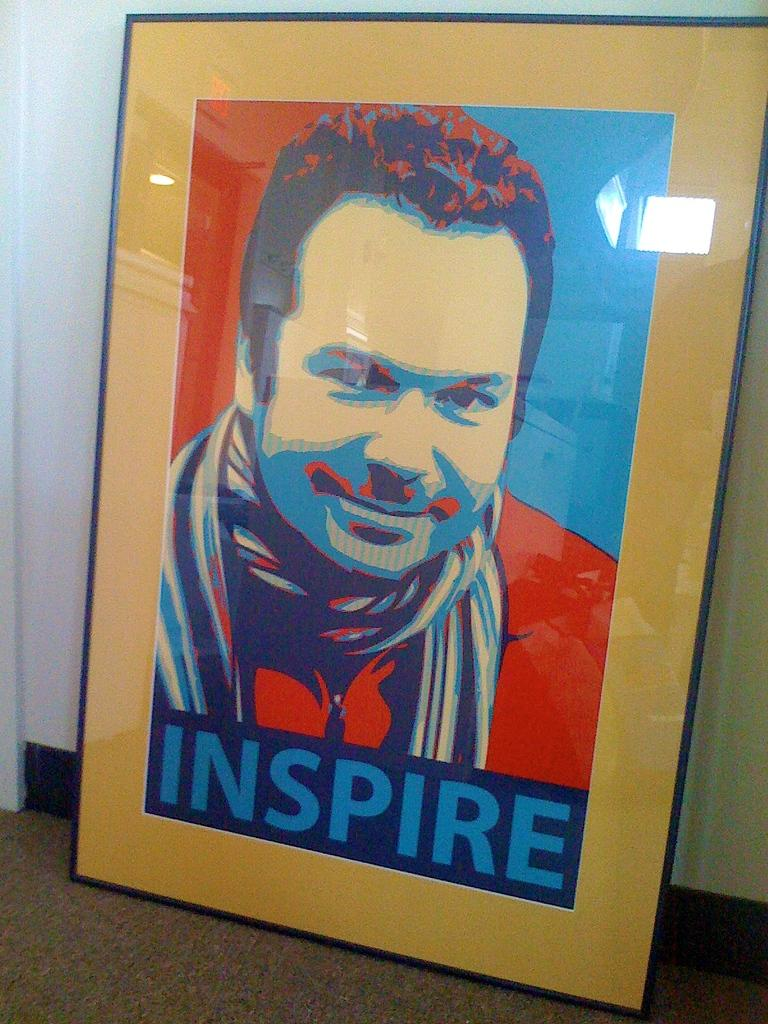What is the main object in the image? There is a frame in the image. What is depicted within the frame? The frame contains a painting of a person. Are there any words or letters on the frame? Yes, there is text on the frame. What can be seen behind the frame in the image? There is a wall visible at the back of the image. What is present at the bottom of the frame in the image? There is a mat at the bottom of the image. What type of steel is used to make the sack in the image? There is no sack or steel present in the image. 